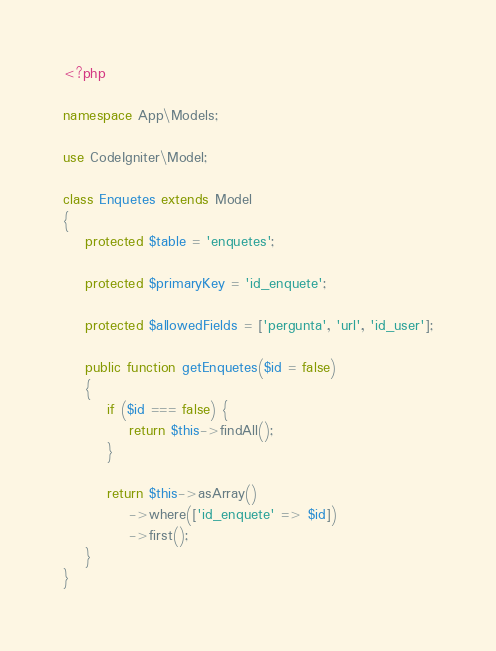Convert code to text. <code><loc_0><loc_0><loc_500><loc_500><_PHP_><?php

namespace App\Models;

use CodeIgniter\Model;

class Enquetes extends Model
{
    protected $table = 'enquetes';

    protected $primaryKey = 'id_enquete';

    protected $allowedFields = ['pergunta', 'url', 'id_user'];

    public function getEnquetes($id = false)
    {
        if ($id === false) {
            return $this->findAll();
        }

        return $this->asArray()
            ->where(['id_enquete' => $id])
            ->first();
    }
}
</code> 